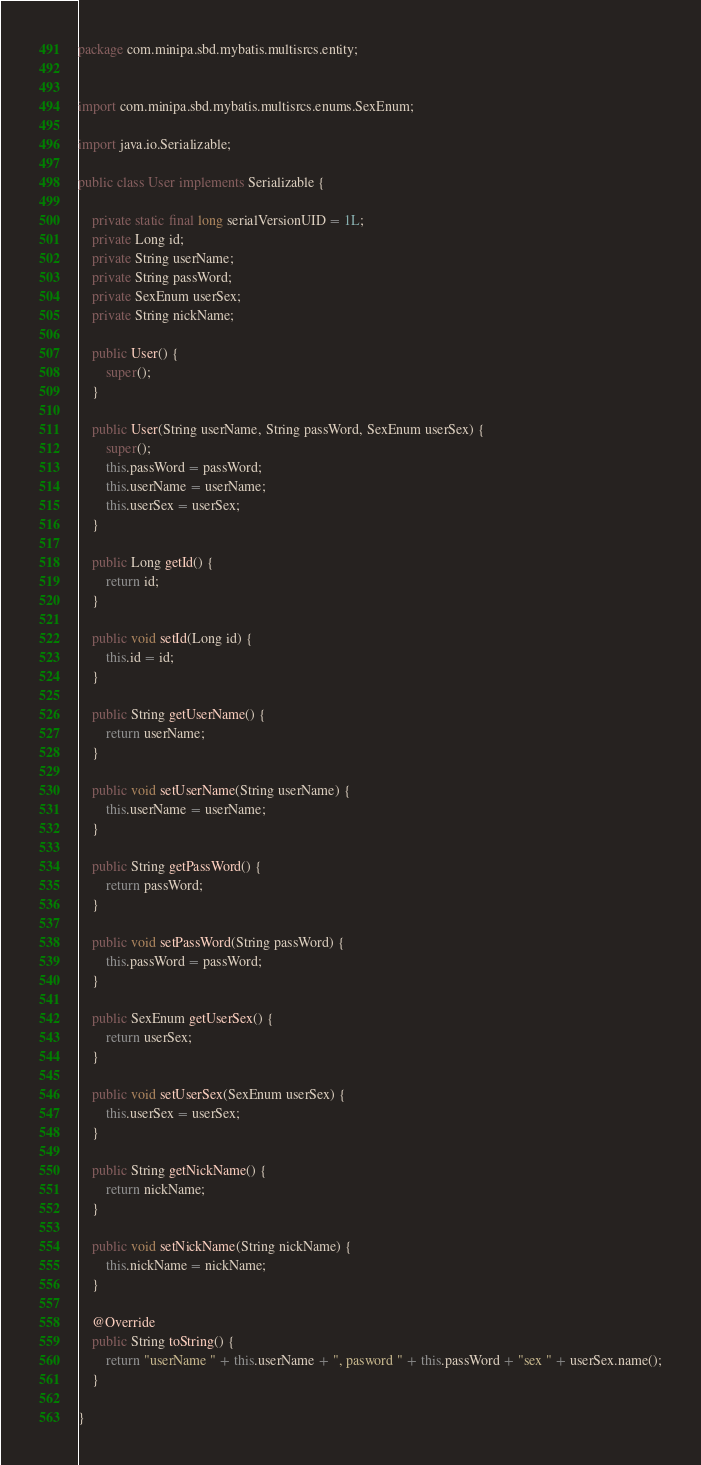<code> <loc_0><loc_0><loc_500><loc_500><_Java_>package com.minipa.sbd.mybatis.multisrcs.entity;


import com.minipa.sbd.mybatis.multisrcs.enums.SexEnum;

import java.io.Serializable;

public class User implements Serializable {

	private static final long serialVersionUID = 1L;
	private Long id;
	private String userName;
	private String passWord;
	private SexEnum userSex;
	private String nickName;

	public User() {
		super();
	}

	public User(String userName, String passWord, SexEnum userSex) {
		super();
		this.passWord = passWord;
		this.userName = userName;
		this.userSex = userSex;
	}

	public Long getId() {
		return id;
	}

	public void setId(Long id) {
		this.id = id;
	}

	public String getUserName() {
		return userName;
	}

	public void setUserName(String userName) {
		this.userName = userName;
	}

	public String getPassWord() {
		return passWord;
	}

	public void setPassWord(String passWord) {
		this.passWord = passWord;
	}

	public SexEnum getUserSex() {
		return userSex;
	}

	public void setUserSex(SexEnum userSex) {
		this.userSex = userSex;
	}

	public String getNickName() {
		return nickName;
	}

	public void setNickName(String nickName) {
		this.nickName = nickName;
	}

	@Override
	public String toString() {
		return "userName " + this.userName + ", pasword " + this.passWord + "sex " + userSex.name();
	}

}</code> 